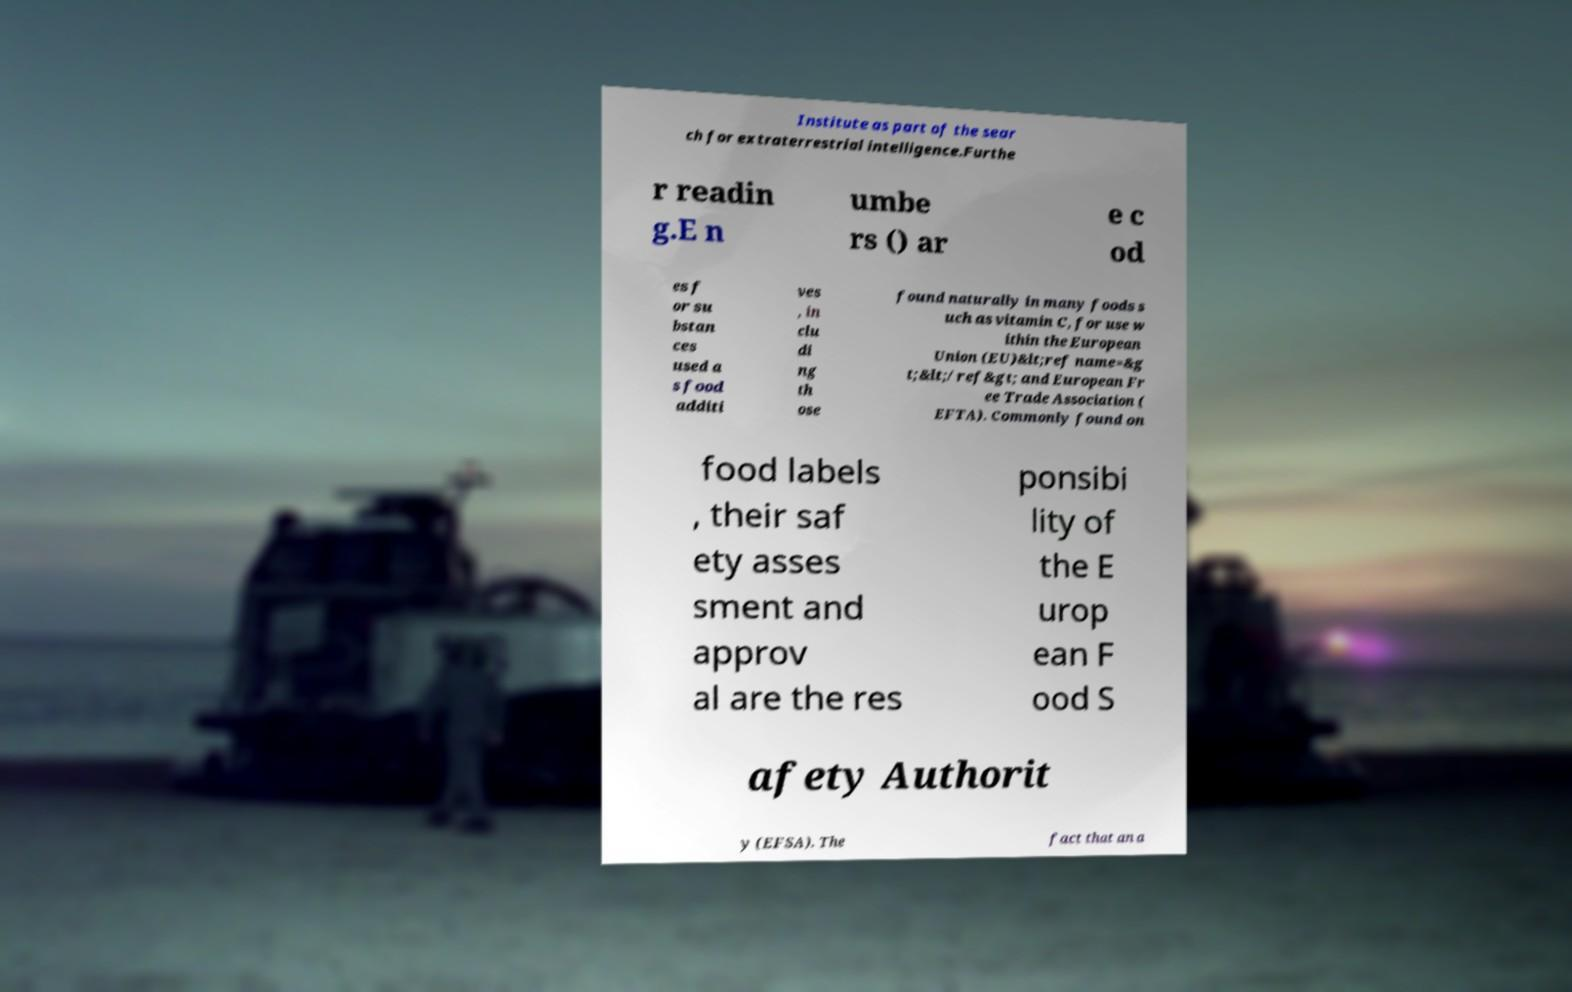For documentation purposes, I need the text within this image transcribed. Could you provide that? Institute as part of the sear ch for extraterrestrial intelligence.Furthe r readin g.E n umbe rs () ar e c od es f or su bstan ces used a s food additi ves , in clu di ng th ose found naturally in many foods s uch as vitamin C, for use w ithin the European Union (EU)&lt;ref name=&g t;&lt;/ref&gt; and European Fr ee Trade Association ( EFTA). Commonly found on food labels , their saf ety asses sment and approv al are the res ponsibi lity of the E urop ean F ood S afety Authorit y (EFSA). The fact that an a 